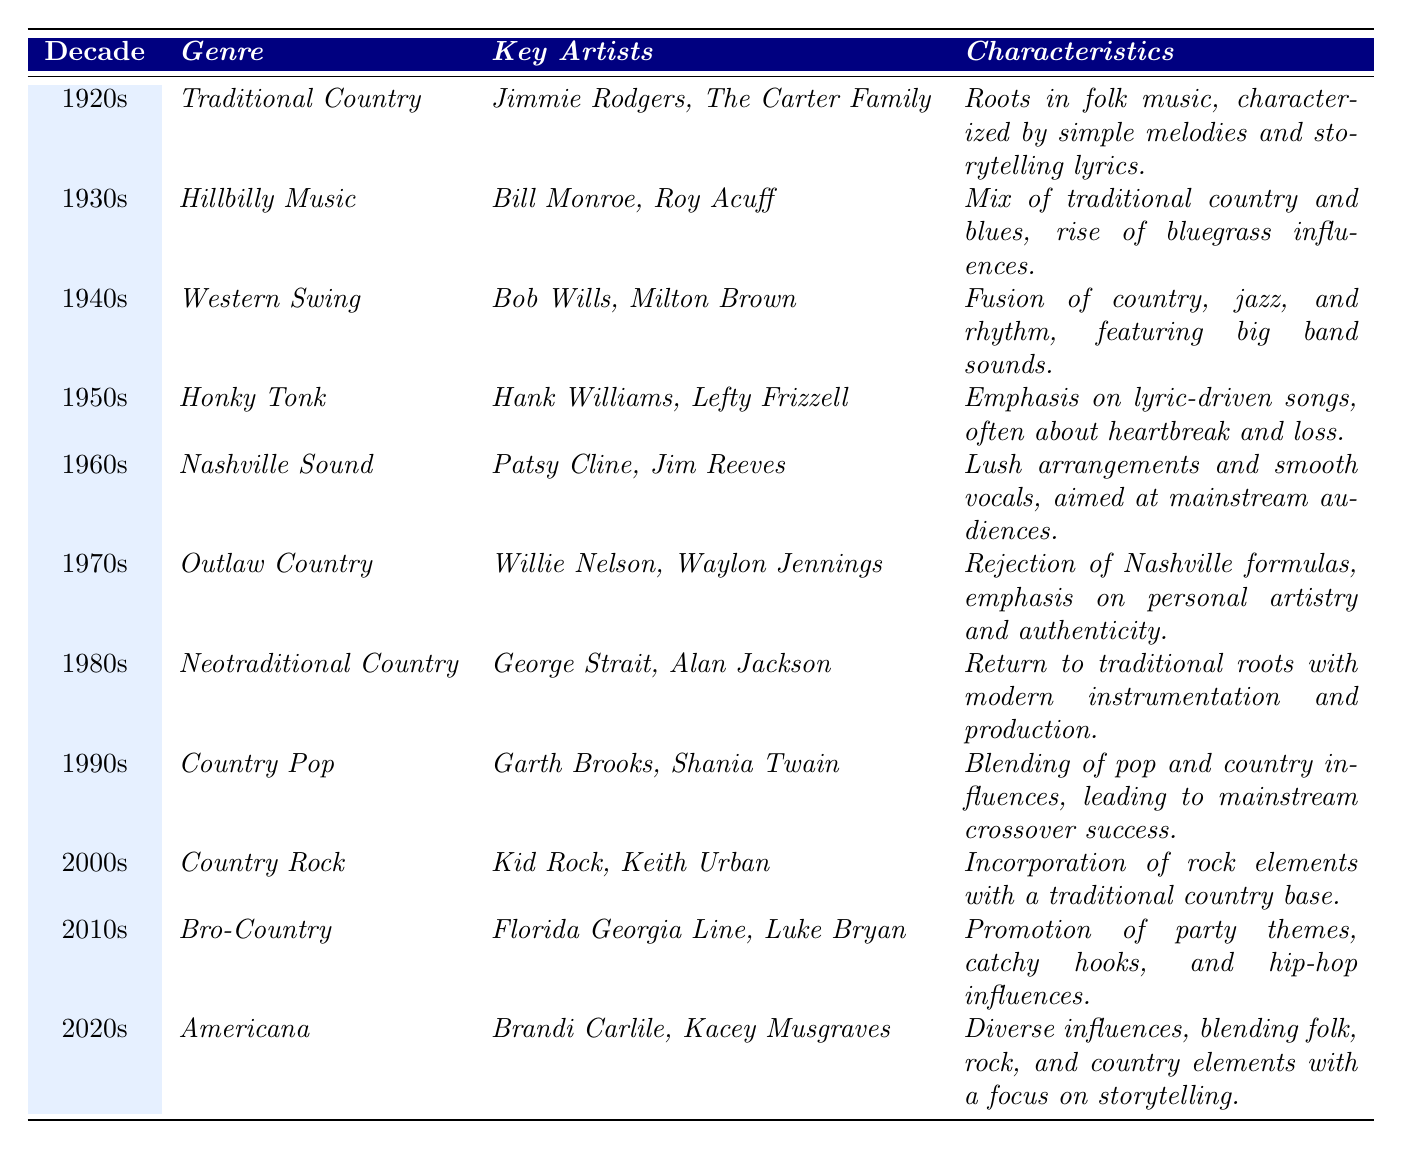What genre was prevalent in the 1950s? The table lists "Honky Tonk" as the genre for the 1950s under the "Genre" column.
Answer: Honky Tonk Who are the key artists associated with Outlaw Country? According to the table, the key artists for Outlaw Country in the 1970s are Willie Nelson and Waylon Jennings.
Answer: Willie Nelson, Waylon Jennings What decade saw the rise of the Nashville Sound? The table indicates that the Nashville Sound was prominent in the 1960s under the "Decade" column.
Answer: 1960s Which genre combines country with rock elements? The 2000s genre listed in the table is "Country Rock," which specifically incorporates rock elements with traditional country.
Answer: Country Rock Is it true that the 1930s genre was called Hillbilly Music? The table explicitly states that the genre for the 1930s is Hillbilly Music, making this statement true.
Answer: Yes In which decade did the genre of Country Pop emerge? The table shows that Country Pop emerged in the 1990s, as indicated in the "Decade" column.
Answer: 1990s What characteristics define the Americana genre? According to the table, the Americana genre is defined by diverse influences, blending folk, rock, and country elements, with a focus on storytelling.
Answer: Diverse influences, blending folk, rock, and country Compare the primary characteristics of Honky Tonk and Outlaw Country. Honky Tonk is characterized by lyric-driven songs often about heartbreak, while Outlaw Country rejects Nashville formulas, emphasizing personal artistry and authenticity.
Answer: Different lyrical focus and authenticity emphasis How many genres were listed in the table for the 2000s and 2010s? The table lists two genres for these decades: "Country Rock" for the 2000s and "Bro-Country" for the 2010s, making a total of two genres.
Answer: 2 Which genre had key artists like Jimmie Rodgers and The Carter Family? The table identifies "Traditional Country" as the genre for the 1920s, associated with these artists.
Answer: Traditional Country What is the trend of the genres from the 1920s to the 2020s regarding complexity? Analyzing the genres from traditional and folk roots in the 1920s to diverse Americanna in the 2020s, there is an increasing complexity and blending of various musical influences over time.
Answer: Increasing complexity 